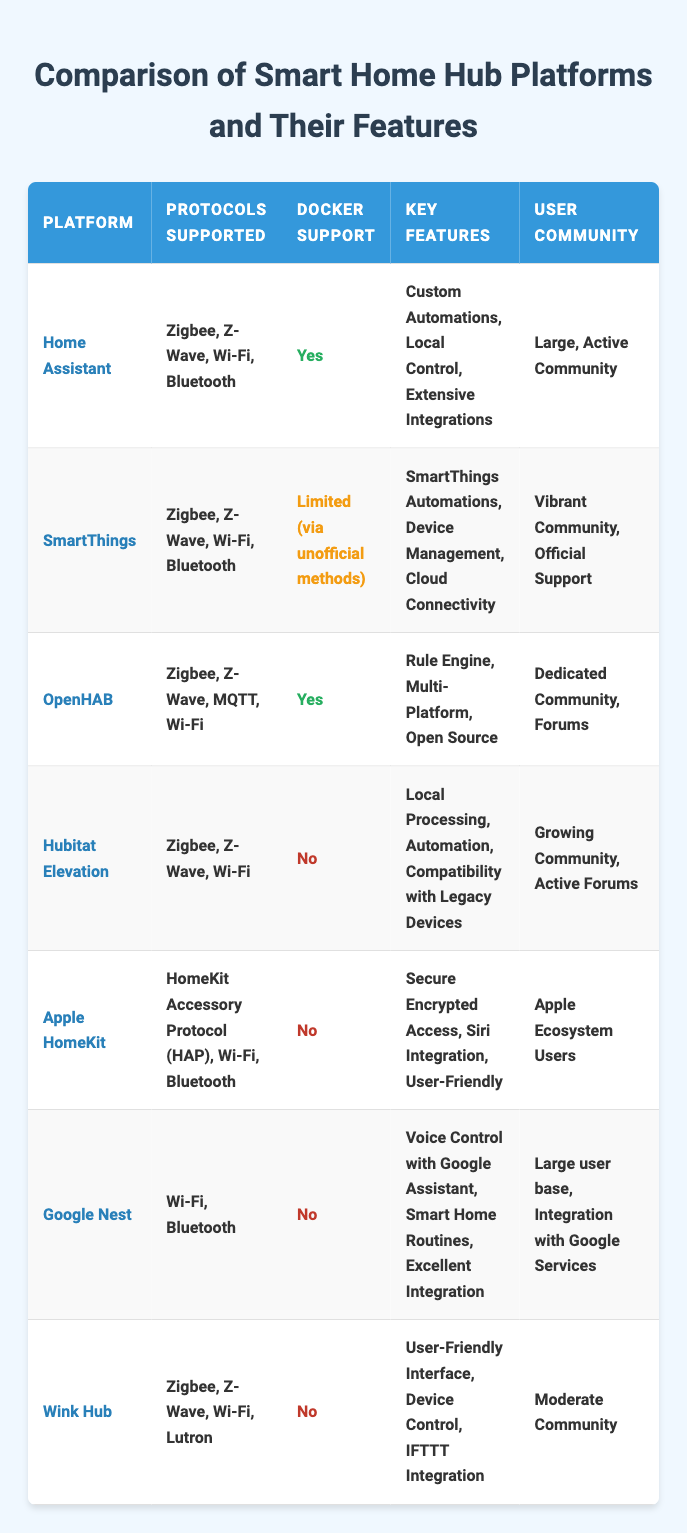What platforms support Docker? From the table, only Home Assistant and OpenHAB have "Yes" listed under Docker Support.
Answer: Home Assistant, OpenHAB Which platform is the most expensive? The only platform with a listed price is Hubitat Elevation at $149, while the others are free or have a one-time fee under $149.
Answer: Hubitat Elevation Is Apple HomeKit free? According to the table, Apple HomeKit is listed as "Free (with Apple Devices)," indicating no additional cost beyond purchasing Apple Devices.
Answer: Yes How many platforms support Zigbee? By counting the platforms that mention Zigbee under "Protocols Supported," we find Home Assistant, SmartThings, OpenHAB, Hubitat Elevation, and Wink Hub, giving us a total of five.
Answer: Five Does Hubitat Elevation support Docker? The table explicitly states that Hubitat Elevation has "No" listed under Docker Support, confirming it does not support Docker.
Answer: No What are the key features of OpenHAB? The table lists the key features of OpenHAB as "Rule Engine, Multi-Platform, Open Source."
Answer: Rule Engine, Multi-Platform, Open Source Which platform has the largest community? Home Assistant is described as having a "Large, Active Community" compared to the others, making it the most recognized for its community support.
Answer: Home Assistant Which platforms support Z-Wave and are free? The platforms that support Z-Wave and are free include Home Assistant and OpenHAB, as both are listed as "Free (Open Source)."
Answer: Home Assistant, OpenHAB Among the platforms listed, which one has no community? None of the platforms list "No community," as each one states some form of a user community, either large, vibrant, or growing.
Answer: None Which platform has a vibrant community and limited Docker support? SmartThings is characterized by a "Vibrant Community, Official Support" while also having "Limited (via unofficial methods)" for Docker support.
Answer: SmartThings 